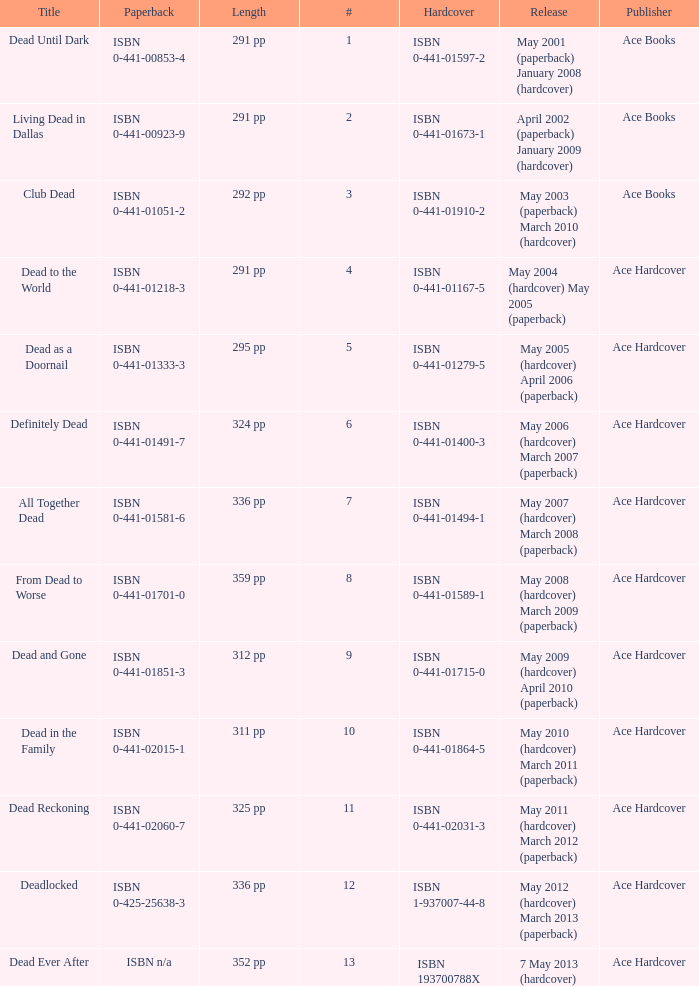Who pubilshed isbn 1-937007-44-8? Ace Hardcover. Could you parse the entire table as a dict? {'header': ['Title', 'Paperback', 'Length', '#', 'Hardcover', 'Release', 'Publisher'], 'rows': [['Dead Until Dark', 'ISBN 0-441-00853-4', '291 pp', '1', 'ISBN 0-441-01597-2', 'May 2001 (paperback) January 2008 (hardcover)', 'Ace Books'], ['Living Dead in Dallas', 'ISBN 0-441-00923-9', '291 pp', '2', 'ISBN 0-441-01673-1', 'April 2002 (paperback) January 2009 (hardcover)', 'Ace Books'], ['Club Dead', 'ISBN 0-441-01051-2', '292 pp', '3', 'ISBN 0-441-01910-2', 'May 2003 (paperback) March 2010 (hardcover)', 'Ace Books'], ['Dead to the World', 'ISBN 0-441-01218-3', '291 pp', '4', 'ISBN 0-441-01167-5', 'May 2004 (hardcover) May 2005 (paperback)', 'Ace Hardcover'], ['Dead as a Doornail', 'ISBN 0-441-01333-3', '295 pp', '5', 'ISBN 0-441-01279-5', 'May 2005 (hardcover) April 2006 (paperback)', 'Ace Hardcover'], ['Definitely Dead', 'ISBN 0-441-01491-7', '324 pp', '6', 'ISBN 0-441-01400-3', 'May 2006 (hardcover) March 2007 (paperback)', 'Ace Hardcover'], ['All Together Dead', 'ISBN 0-441-01581-6', '336 pp', '7', 'ISBN 0-441-01494-1', 'May 2007 (hardcover) March 2008 (paperback)', 'Ace Hardcover'], ['From Dead to Worse', 'ISBN 0-441-01701-0', '359 pp', '8', 'ISBN 0-441-01589-1', 'May 2008 (hardcover) March 2009 (paperback)', 'Ace Hardcover'], ['Dead and Gone', 'ISBN 0-441-01851-3', '312 pp', '9', 'ISBN 0-441-01715-0', 'May 2009 (hardcover) April 2010 (paperback)', 'Ace Hardcover'], ['Dead in the Family', 'ISBN 0-441-02015-1', '311 pp', '10', 'ISBN 0-441-01864-5', 'May 2010 (hardcover) March 2011 (paperback)', 'Ace Hardcover'], ['Dead Reckoning', 'ISBN 0-441-02060-7', '325 pp', '11', 'ISBN 0-441-02031-3', 'May 2011 (hardcover) March 2012 (paperback)', 'Ace Hardcover'], ['Deadlocked', 'ISBN 0-425-25638-3', '336 pp', '12', 'ISBN 1-937007-44-8', 'May 2012 (hardcover) March 2013 (paperback)', 'Ace Hardcover'], ['Dead Ever After', 'ISBN n/a', '352 pp', '13', 'ISBN 193700788X', '7 May 2013 (hardcover)', 'Ace Hardcover']]} 